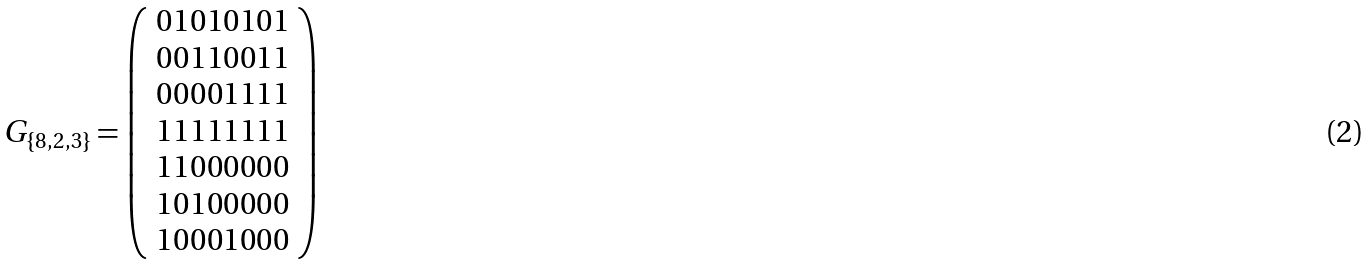<formula> <loc_0><loc_0><loc_500><loc_500>G _ { \{ 8 , 2 , 3 \} } = \left ( \begin{array} { c } 0 1 0 1 0 1 0 1 \\ 0 0 1 1 0 0 1 1 \\ 0 0 0 0 1 1 1 1 \\ 1 1 1 1 1 1 1 1 \\ 1 1 0 0 0 0 0 0 \\ 1 0 1 0 0 0 0 0 \\ 1 0 0 0 1 0 0 0 \end{array} \right )</formula> 